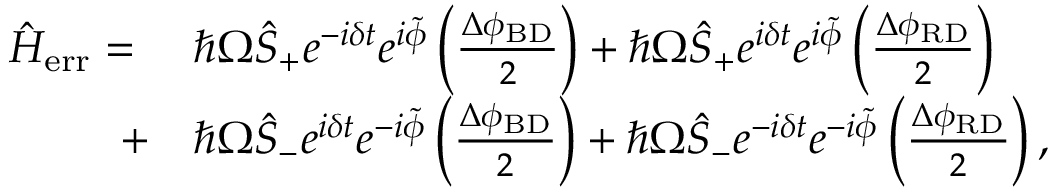<formula> <loc_0><loc_0><loc_500><loc_500>\begin{array} { r l } { \hat { H } _ { e r r } = \ } & { \hbar { \Omega } \hat { S } _ { + } e ^ { - i \delta t } e ^ { i \tilde { \phi } } \left ( \frac { \Delta \phi _ { B D } } { 2 } \right ) + \hbar { \Omega } \hat { S } _ { + } e ^ { i \delta t } e ^ { i \tilde { \phi } } \left ( \frac { \Delta \phi _ { R D } } { 2 } \right ) } \\ { + } & { \hbar { \Omega } \hat { S } _ { - } e ^ { i \delta t } e ^ { - i \tilde { \phi } } \left ( \frac { \Delta \phi _ { B D } } { 2 } \right ) + \hbar { \Omega } \hat { S } _ { - } e ^ { - i \delta t } e ^ { - i \tilde { \phi } } \left ( \frac { \Delta \phi _ { R D } } { 2 } \right ) , } \end{array}</formula> 